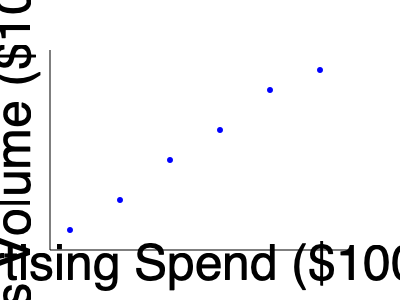Based on the scatter plot showing the relationship between advertising spend and sales volume, what type of correlation appears to exist between these variables, and how might this information be used to inform demand forecasting strategies for our retail company? To analyze the correlation between advertising spend and sales volume, we should follow these steps:

1. Examine the overall pattern of the data points:
   The points generally move from the bottom-left to the top-right of the graph.

2. Determine the direction of the relationship:
   As advertising spend increases, sales volume tends to increase as well.

3. Assess the strength of the relationship:
   The points form a relatively tight pattern around an imaginary line, indicating a strong relationship.

4. Identify the type of correlation:
   The relationship appears to be negative (inverse) and roughly linear.

5. Interpret the correlation:
   There is a strong negative linear correlation between advertising spend and sales volume.

6. Consider implications for demand forecasting:
   a. Increased advertising spend is associated with higher sales volumes.
   b. The relationship suggests that advertising can be an effective tool for driving sales.
   c. We can potentially predict sales volume based on planned advertising expenditures.
   d. The model could be used to set advertising budgets to achieve desired sales targets.
   e. However, we should consider diminishing returns, as the effect seems to lessen at higher spend levels.

7. Additional considerations:
   a. Other factors may influence this relationship (e.g., seasonality, competition).
   b. The causality should be carefully examined; correlation does not imply causation.
   c. Regular updates to this analysis would be necessary to maintain its relevance.

This analysis provides valuable insights for developing data-driven demand forecasting strategies and optimizing advertising expenditures to maximize sales volume.
Answer: Strong positive linear correlation; use for predicting sales based on ad spend, optimizing budgets, and informing demand forecasting strategies. 